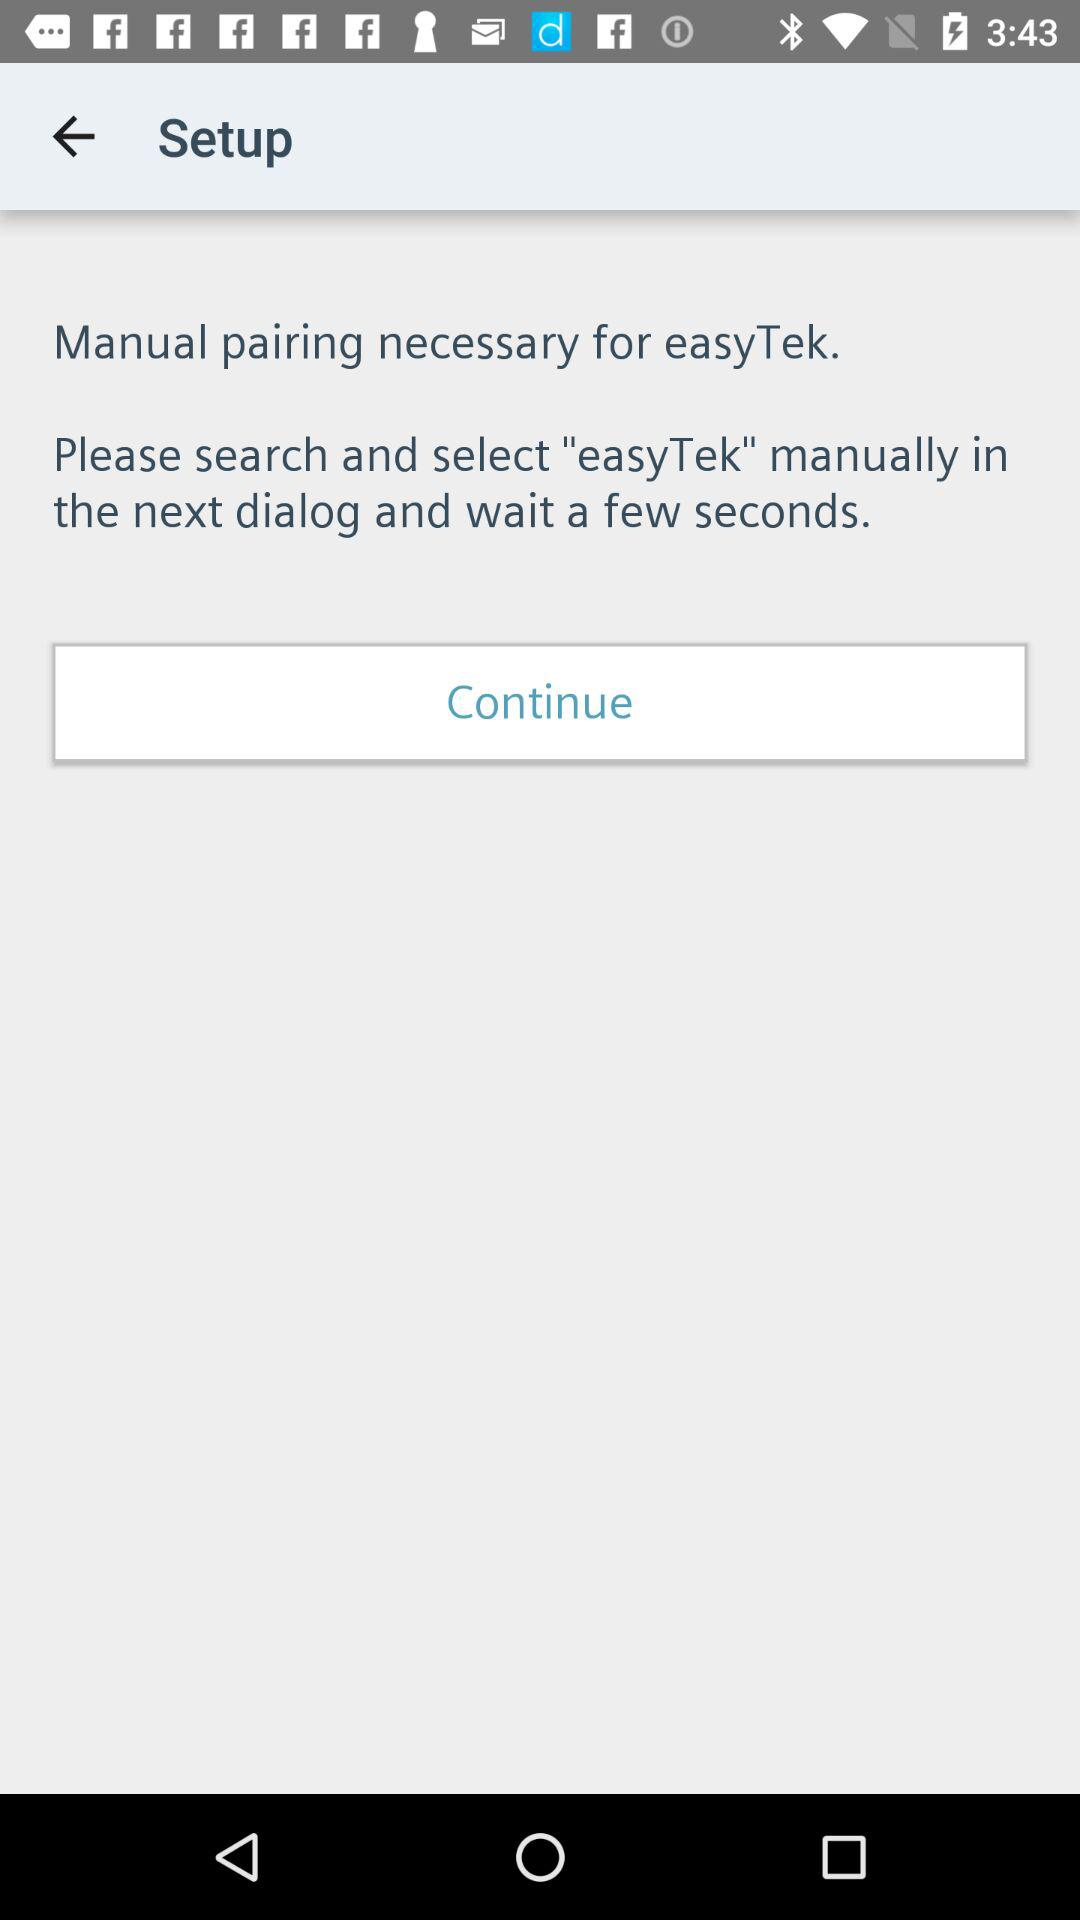What is the application name? The application name is "easyTek". 